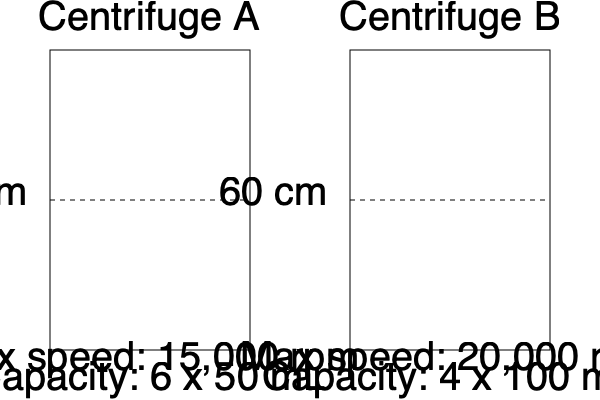Based on the technical drawings and specifications of Centrifuge A and Centrifuge B, which centrifuge has a higher relative centrifugal force (RCF) at its maximum speed, assuming both have the same rotor radius of 10 cm? To determine which centrifuge has a higher relative centrifugal force (RCF) at its maximum speed, we need to calculate the RCF for each centrifuge using the given information. The formula for RCF is:

$$ RCF = 1.12 \times r \times (\frac{rpm}{1000})^2 $$

Where:
- $r$ is the rotor radius in cm
- $rpm$ is the rotations per minute

Step 1: Calculate RCF for Centrifuge A
$$ RCF_A = 1.12 \times 10 \times (\frac{15,000}{1000})^2 = 2,520 \times g $$

Step 2: Calculate RCF for Centrifuge B
$$ RCF_B = 1.12 \times 10 \times (\frac{20,000}{1000})^2 = 4,480 \times g $$

Step 3: Compare the RCF values
Centrifuge B has a higher RCF (4,480 × g) compared to Centrifuge A (2,520 × g).
Answer: Centrifuge B 